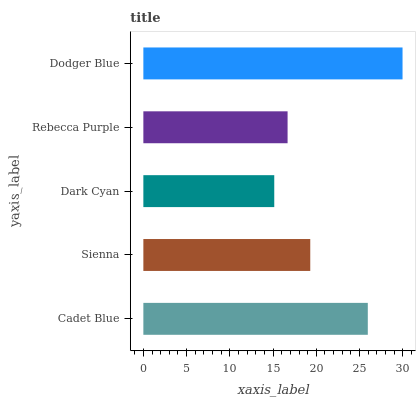Is Dark Cyan the minimum?
Answer yes or no. Yes. Is Dodger Blue the maximum?
Answer yes or no. Yes. Is Sienna the minimum?
Answer yes or no. No. Is Sienna the maximum?
Answer yes or no. No. Is Cadet Blue greater than Sienna?
Answer yes or no. Yes. Is Sienna less than Cadet Blue?
Answer yes or no. Yes. Is Sienna greater than Cadet Blue?
Answer yes or no. No. Is Cadet Blue less than Sienna?
Answer yes or no. No. Is Sienna the high median?
Answer yes or no. Yes. Is Sienna the low median?
Answer yes or no. Yes. Is Rebecca Purple the high median?
Answer yes or no. No. Is Dark Cyan the low median?
Answer yes or no. No. 